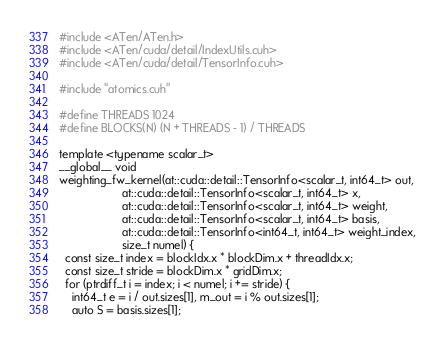Convert code to text. <code><loc_0><loc_0><loc_500><loc_500><_Cuda_>#include <ATen/ATen.h>
#include <ATen/cuda/detail/IndexUtils.cuh>
#include <ATen/cuda/detail/TensorInfo.cuh>

#include "atomics.cuh"

#define THREADS 1024
#define BLOCKS(N) (N + THREADS - 1) / THREADS

template <typename scalar_t>
__global__ void
weighting_fw_kernel(at::cuda::detail::TensorInfo<scalar_t, int64_t> out,
                    at::cuda::detail::TensorInfo<scalar_t, int64_t> x,
                    at::cuda::detail::TensorInfo<scalar_t, int64_t> weight,
                    at::cuda::detail::TensorInfo<scalar_t, int64_t> basis,
                    at::cuda::detail::TensorInfo<int64_t, int64_t> weight_index,
                    size_t numel) {
  const size_t index = blockIdx.x * blockDim.x + threadIdx.x;
  const size_t stride = blockDim.x * gridDim.x;
  for (ptrdiff_t i = index; i < numel; i += stride) {
    int64_t e = i / out.sizes[1], m_out = i % out.sizes[1];
    auto S = basis.sizes[1];</code> 